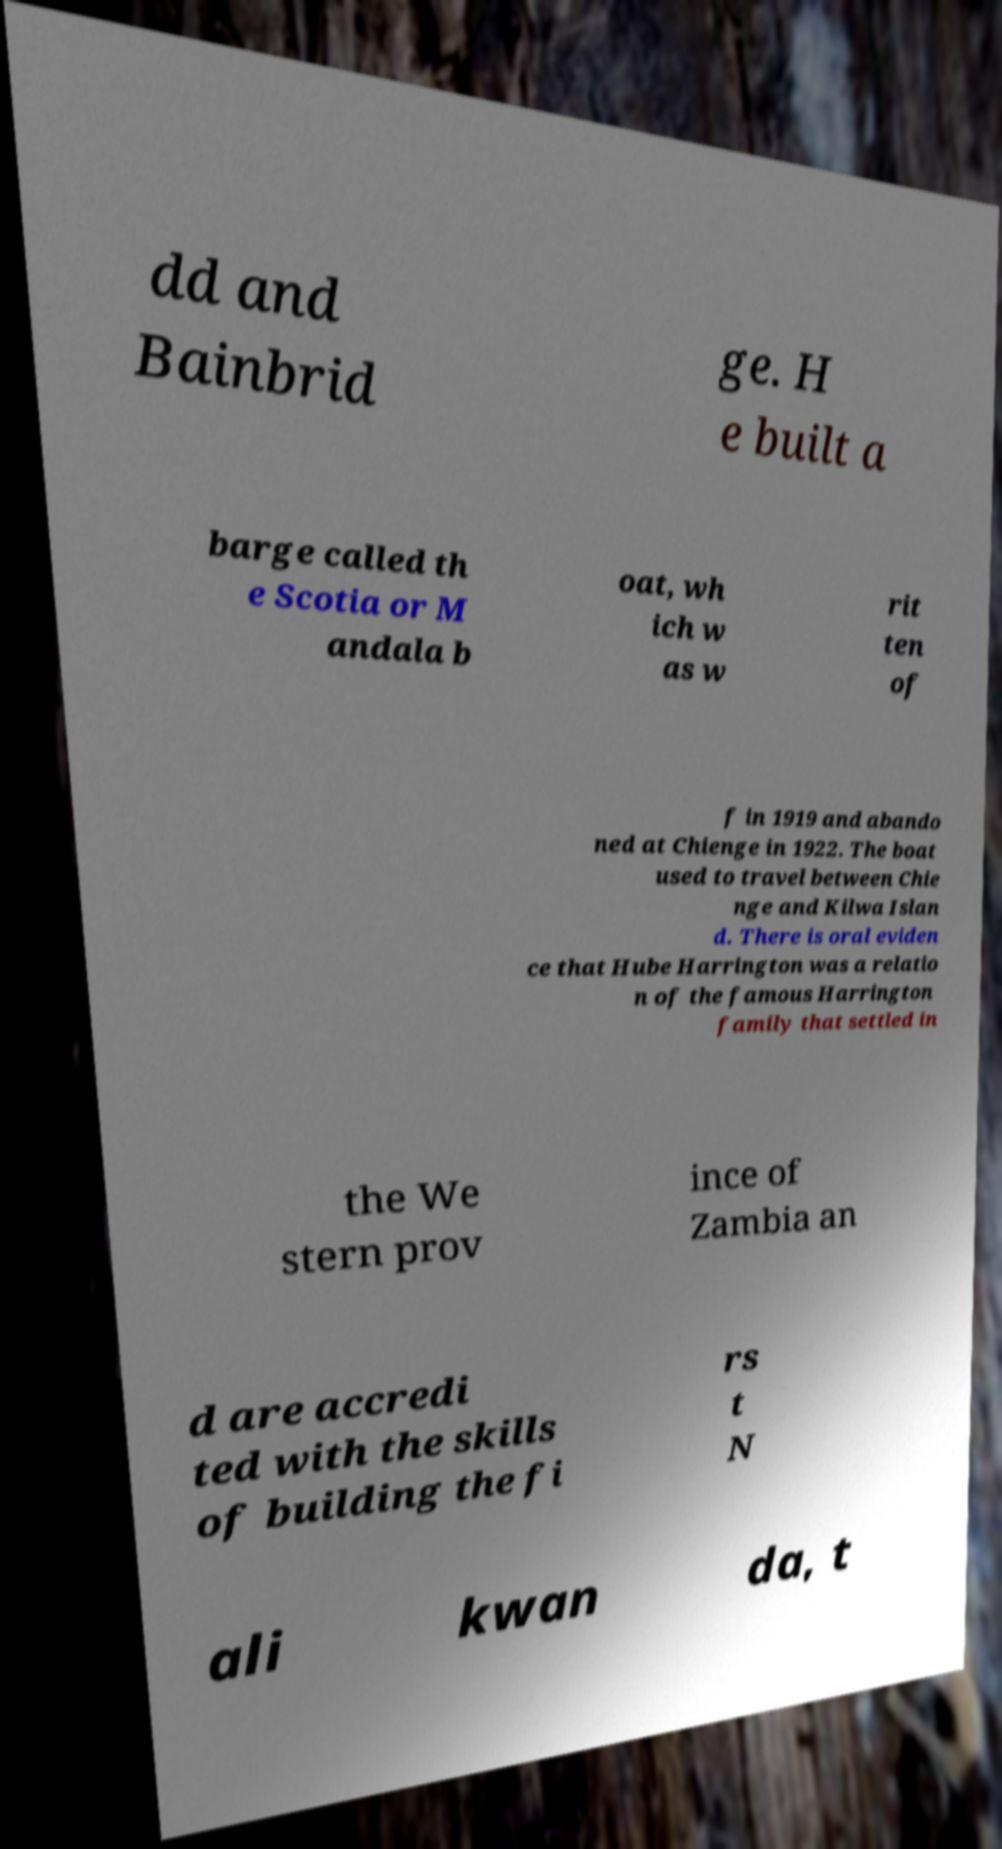I need the written content from this picture converted into text. Can you do that? dd and Bainbrid ge. H e built a barge called th e Scotia or M andala b oat, wh ich w as w rit ten of f in 1919 and abando ned at Chienge in 1922. The boat used to travel between Chie nge and Kilwa Islan d. There is oral eviden ce that Hube Harrington was a relatio n of the famous Harrington family that settled in the We stern prov ince of Zambia an d are accredi ted with the skills of building the fi rs t N ali kwan da, t 